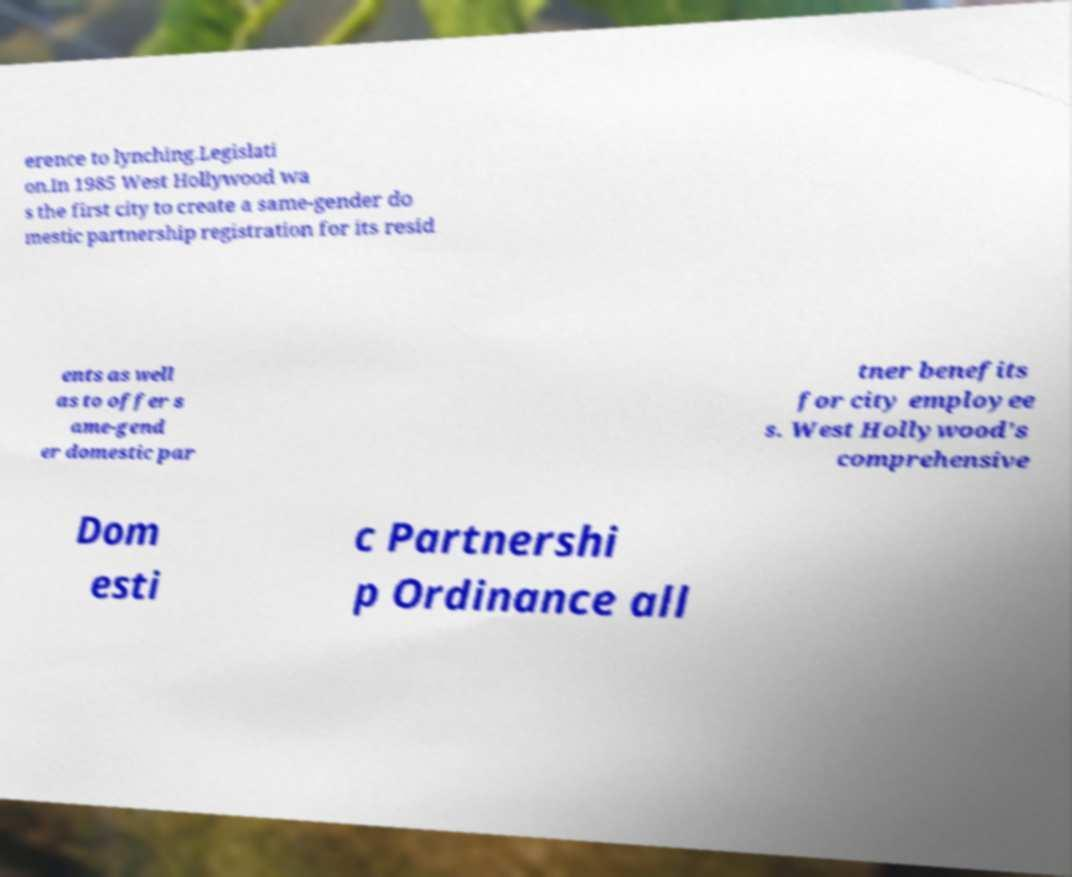Please identify and transcribe the text found in this image. erence to lynching.Legislati on.In 1985 West Hollywood wa s the first city to create a same-gender do mestic partnership registration for its resid ents as well as to offer s ame-gend er domestic par tner benefits for city employee s. West Hollywood's comprehensive Dom esti c Partnershi p Ordinance all 